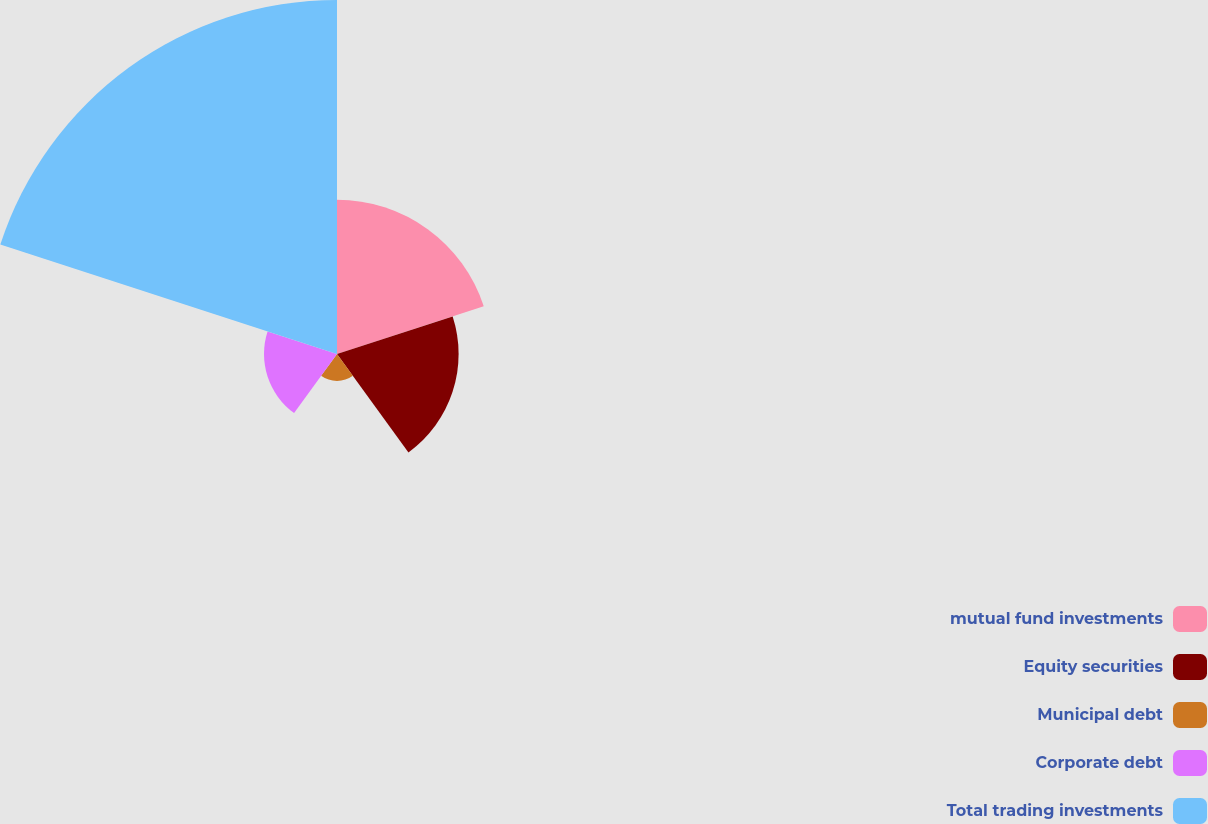<chart> <loc_0><loc_0><loc_500><loc_500><pie_chart><fcel>mutual fund investments<fcel>Equity securities<fcel>Municipal debt<fcel>Corporate debt<fcel>Total trading investments<nl><fcel>21.14%<fcel>16.66%<fcel>3.7%<fcel>10.0%<fcel>48.5%<nl></chart> 